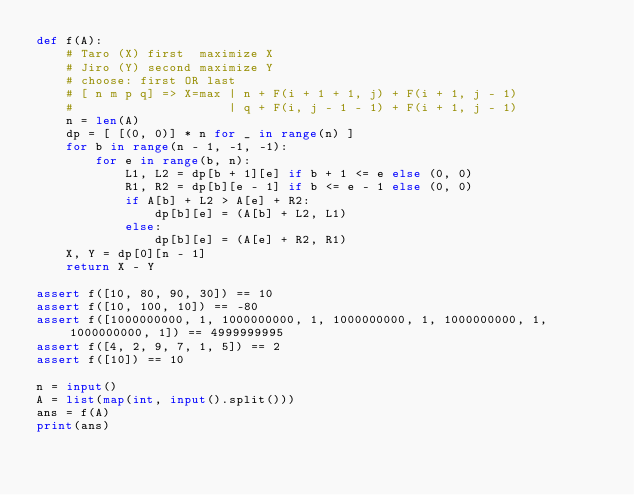<code> <loc_0><loc_0><loc_500><loc_500><_Python_>def f(A):
    # Taro (X) first  maximize X
    # Jiro (Y) second maximize Y
    # choose: first OR last
    # [ n m p q] => X=max | n + F(i + 1 + 1, j) + F(i + 1, j - 1)
    #                     | q + F(i, j - 1 - 1) + F(i + 1, j - 1)
    n = len(A)
    dp = [ [(0, 0)] * n for _ in range(n) ]
    for b in range(n - 1, -1, -1):
        for e in range(b, n):
            L1, L2 = dp[b + 1][e] if b + 1 <= e else (0, 0)
            R1, R2 = dp[b][e - 1] if b <= e - 1 else (0, 0)
            if A[b] + L2 > A[e] + R2:
                dp[b][e] = (A[b] + L2, L1)
            else:
                dp[b][e] = (A[e] + R2, R1)
    X, Y = dp[0][n - 1]
    return X - Y

assert f([10, 80, 90, 30]) == 10
assert f([10, 100, 10]) == -80
assert f([1000000000, 1, 1000000000, 1, 1000000000, 1, 1000000000, 1, 1000000000, 1]) == 4999999995
assert f([4, 2, 9, 7, 1, 5]) == 2
assert f([10]) == 10

n = input()
A = list(map(int, input().split()))
ans = f(A)
print(ans)
</code> 